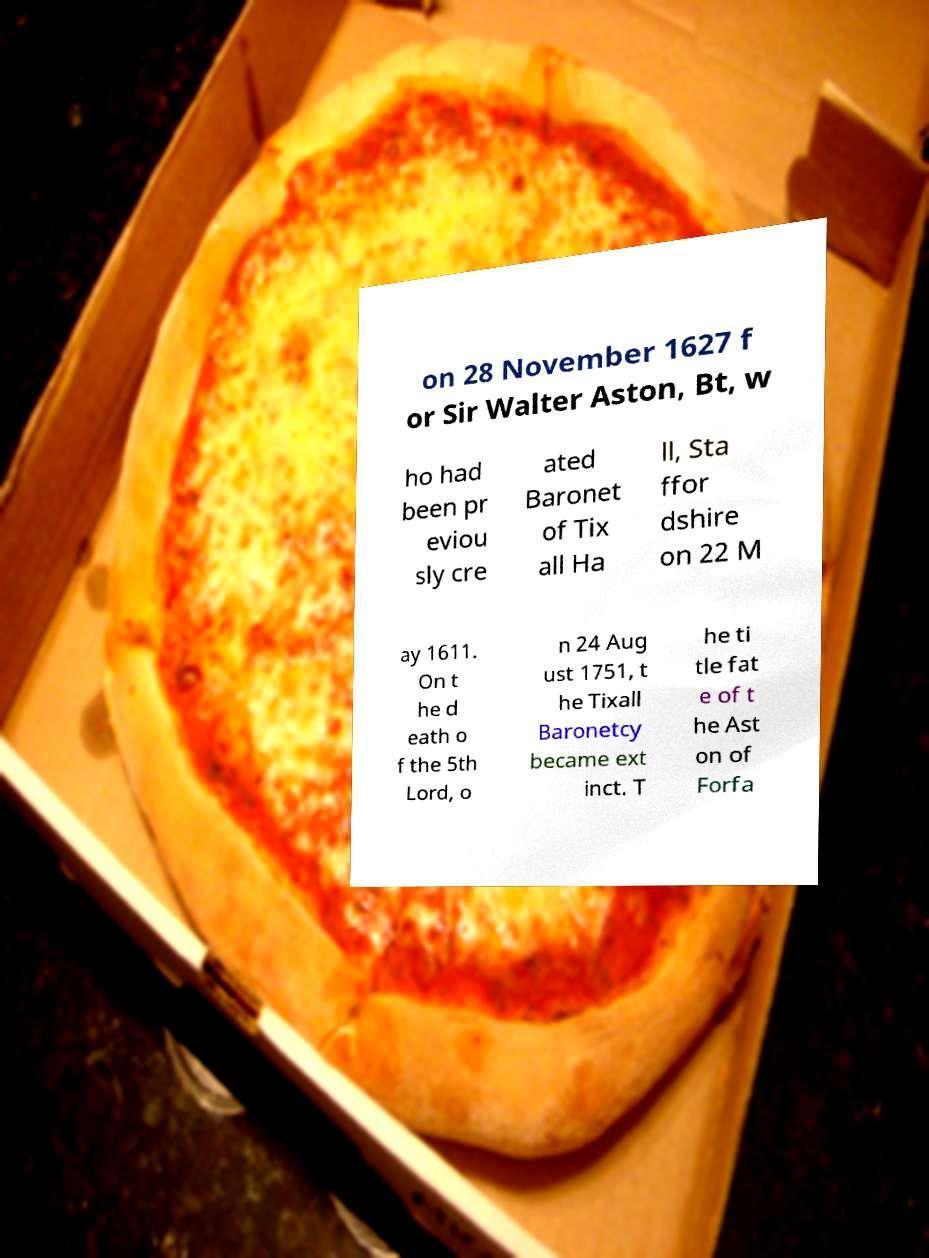Could you extract and type out the text from this image? on 28 November 1627 f or Sir Walter Aston, Bt, w ho had been pr eviou sly cre ated Baronet of Tix all Ha ll, Sta ffor dshire on 22 M ay 1611. On t he d eath o f the 5th Lord, o n 24 Aug ust 1751, t he Tixall Baronetcy became ext inct. T he ti tle fat e of t he Ast on of Forfa 